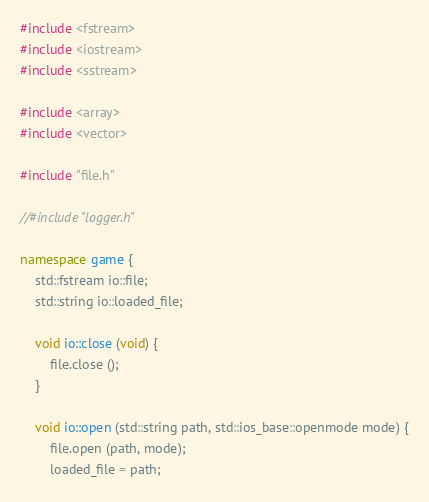Convert code to text. <code><loc_0><loc_0><loc_500><loc_500><_C++_>#include <fstream>
#include <iostream>
#include <sstream>

#include <array>
#include <vector>

#include "file.h"

//#include "logger.h"

namespace game {
	std::fstream io::file;
	std::string io::loaded_file;

	void io::close (void) {
		file.close ();
	}

	void io::open (std::string path, std::ios_base::openmode mode) {
		file.open (path, mode);
		loaded_file = path;</code> 